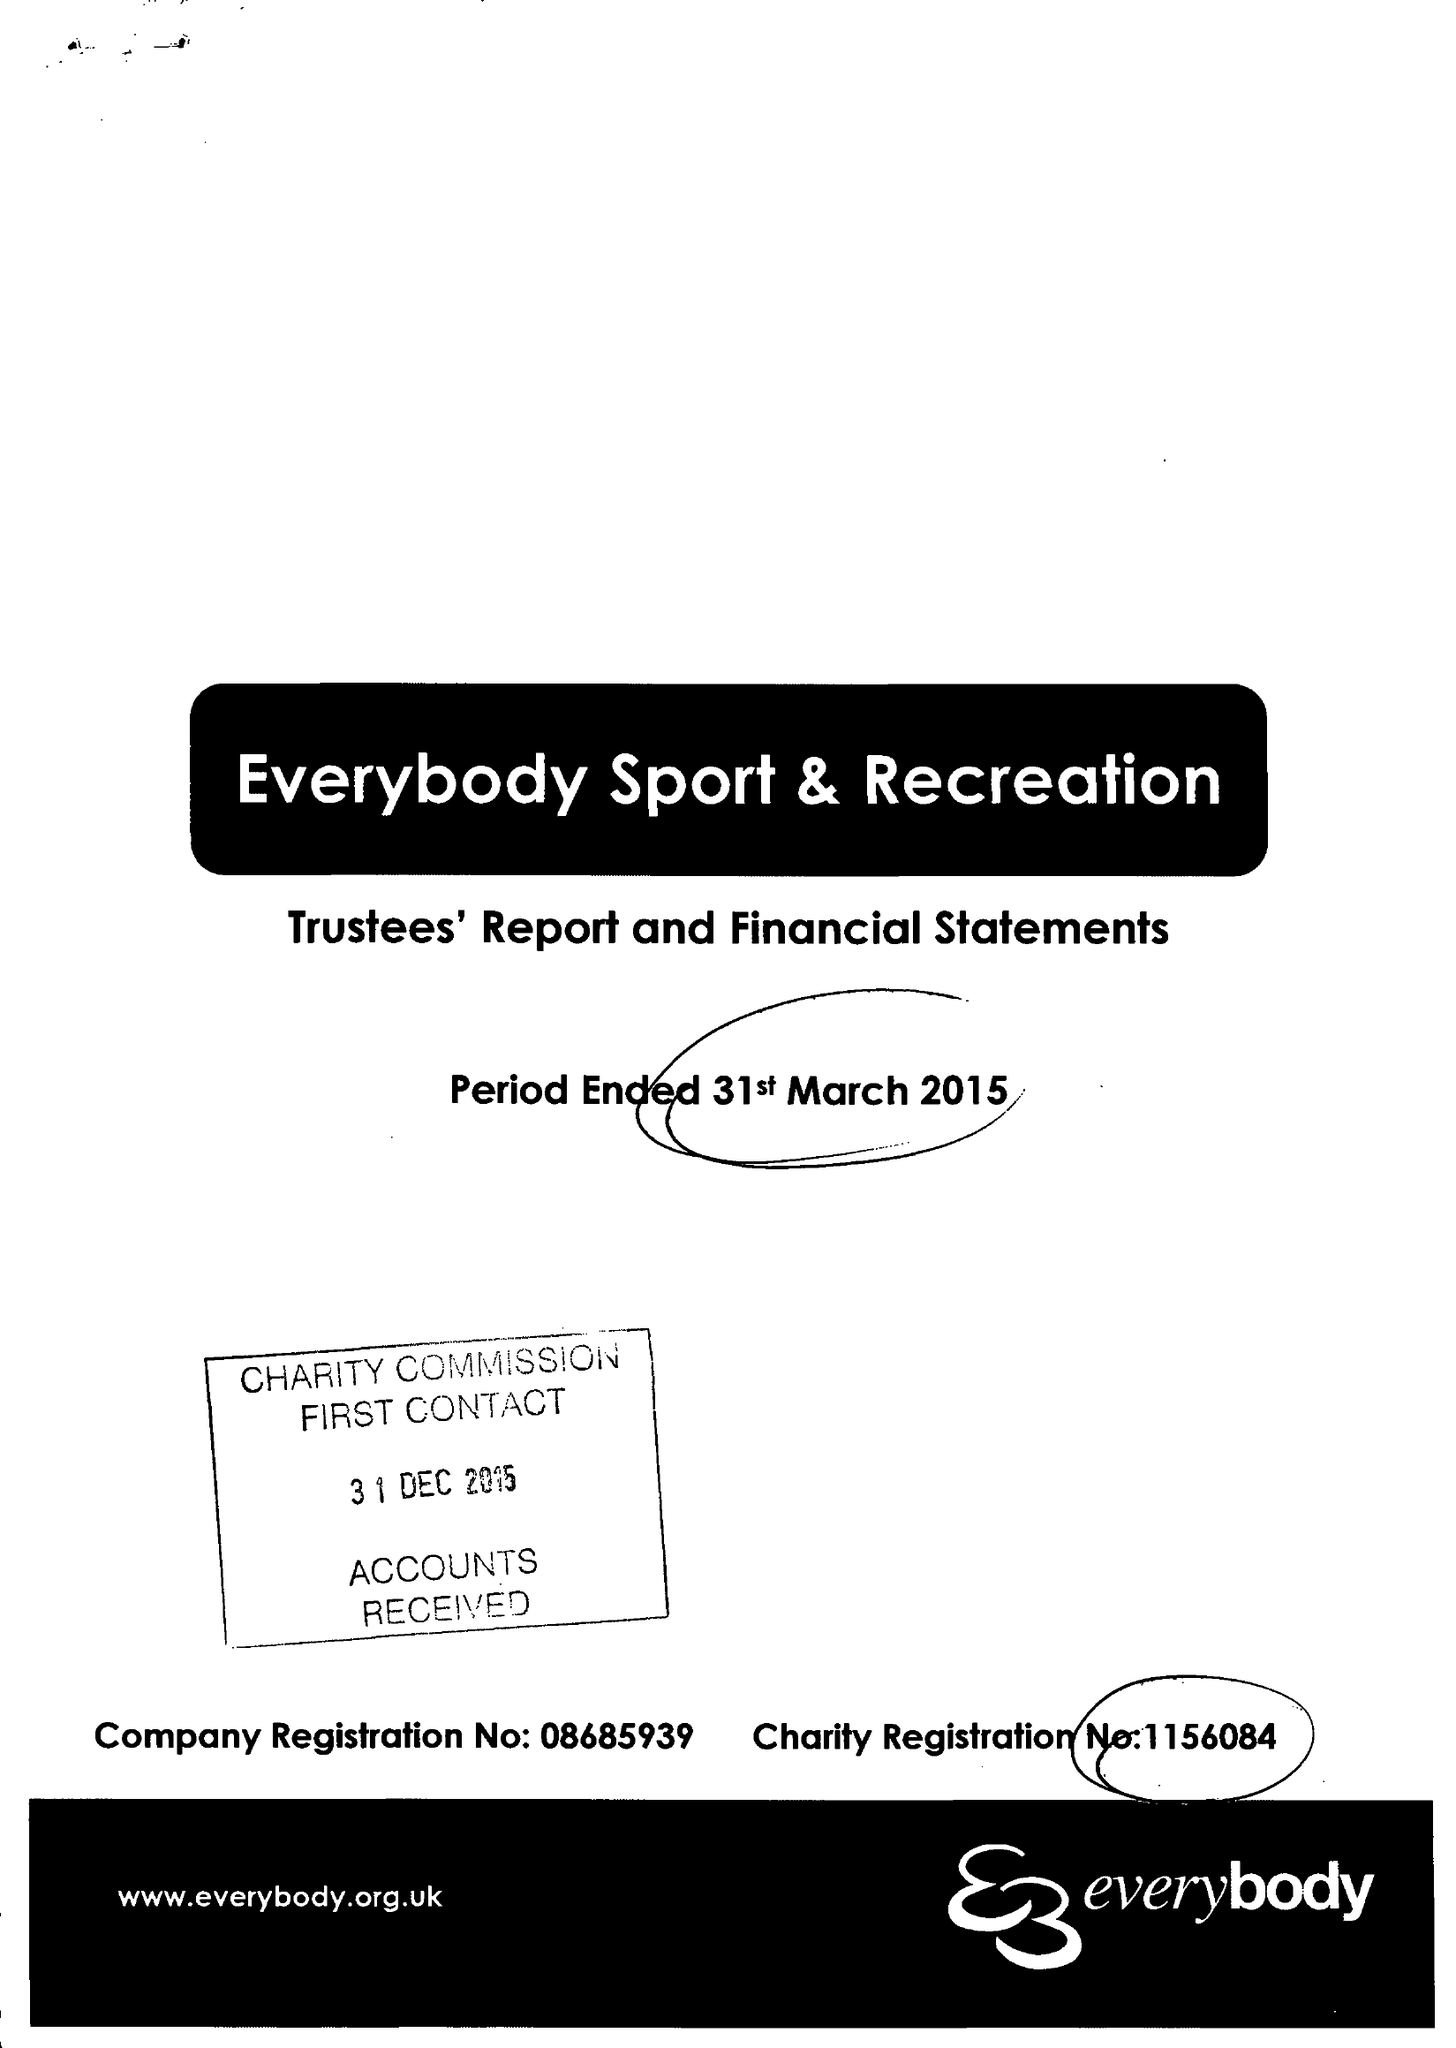What is the value for the address__street_line?
Answer the question using a single word or phrase. STATION ROAD 